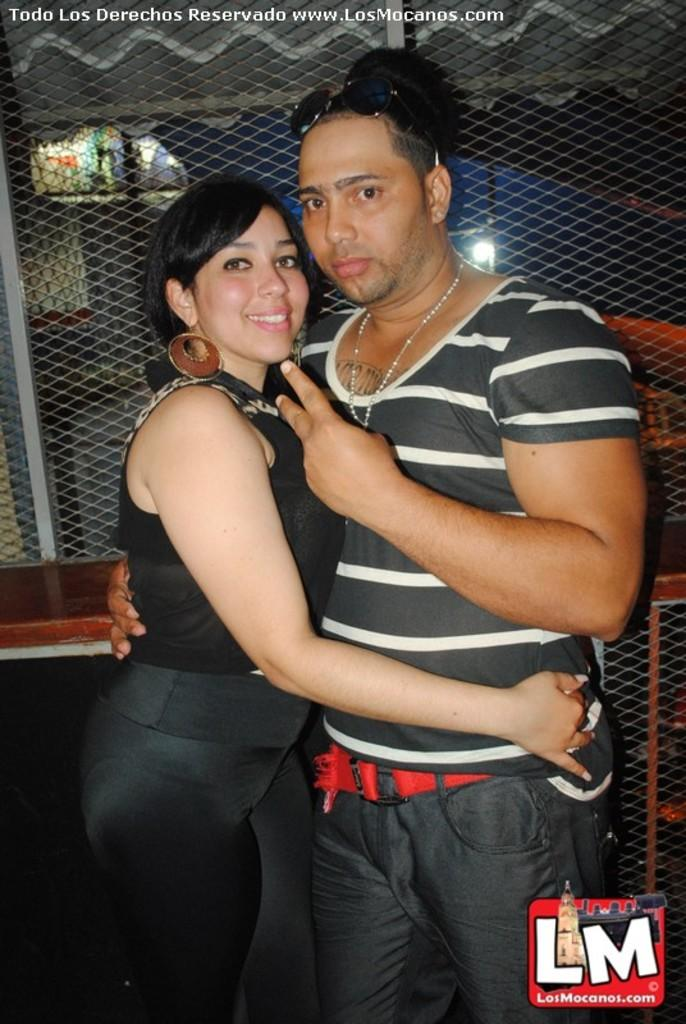How many people are in the image? There are two persons standing in the image. What are the colors of the dresses worn by the persons? The person on the right is wearing a black and white dress, and the person on the left is wearing a black dress. What can be seen in the background of the image? There is railing visible in the background of the image. How many ladybugs can be seen on the sidewalk in the image? There are no ladybugs visible in the image. 